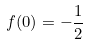Convert formula to latex. <formula><loc_0><loc_0><loc_500><loc_500>f ( 0 ) = - \frac { 1 } { 2 }</formula> 